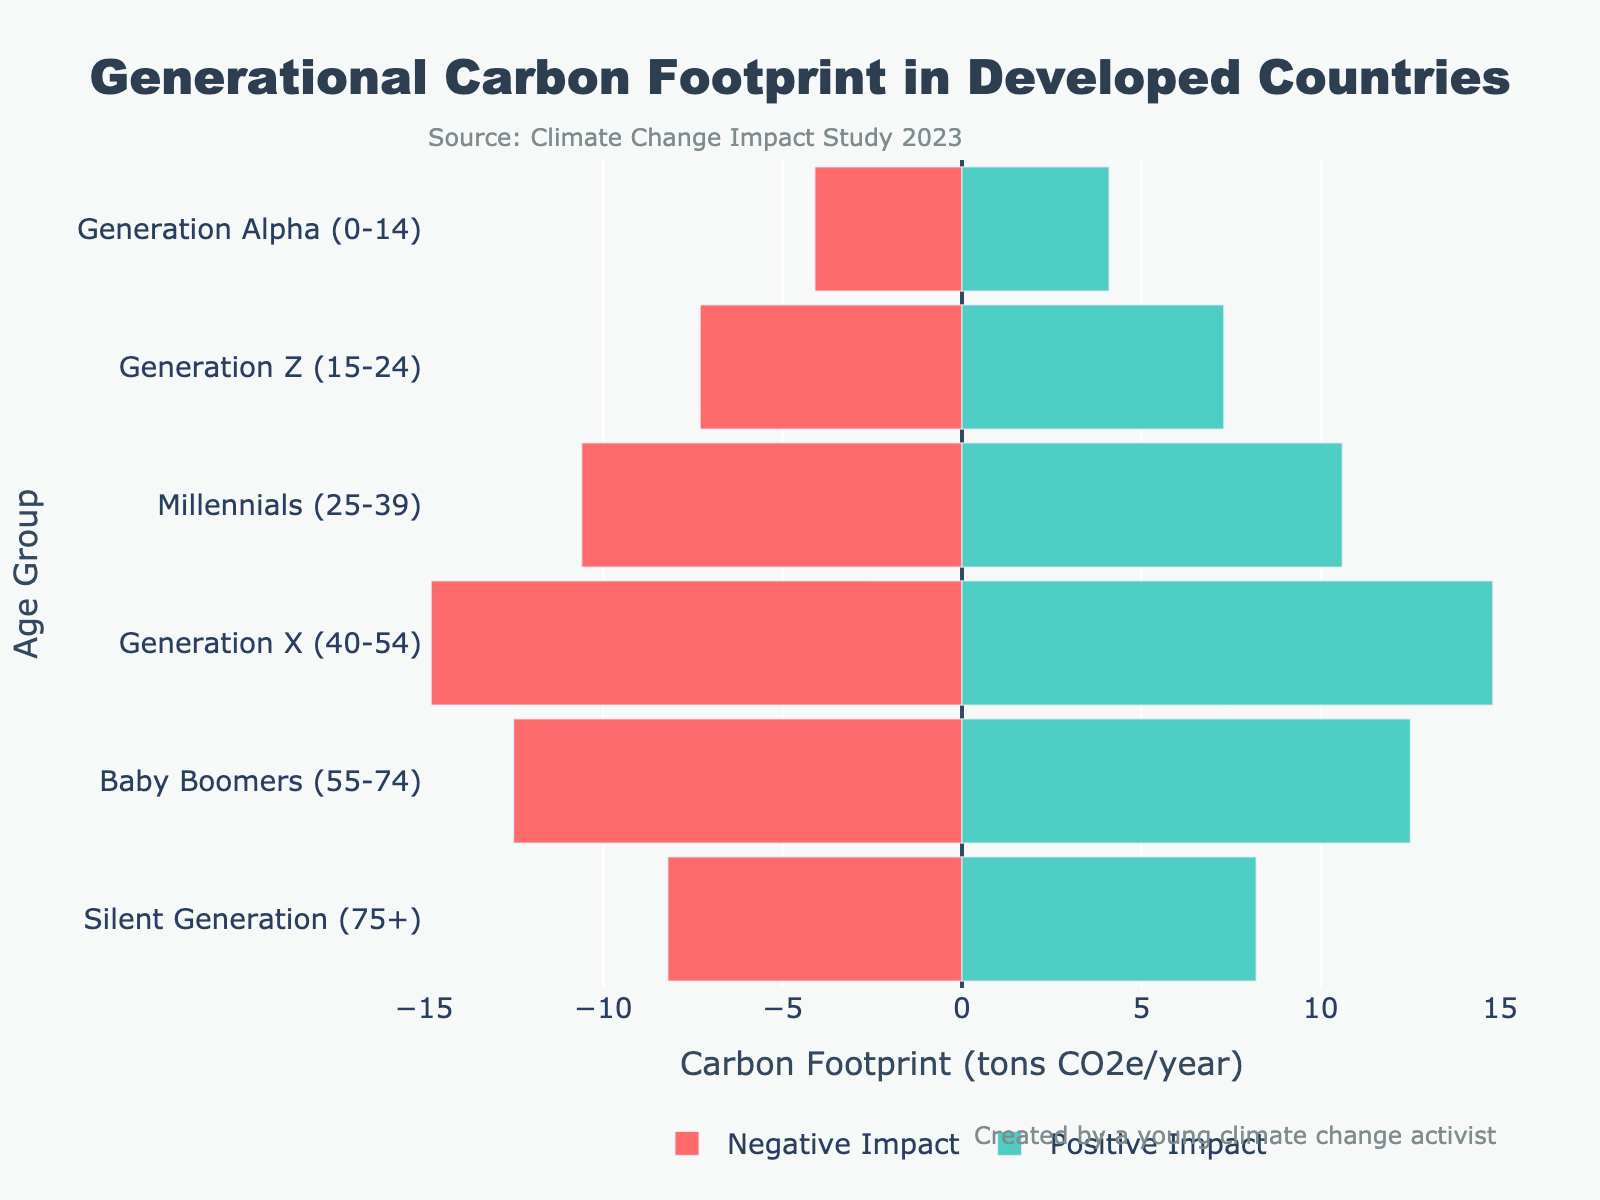What is the carbon footprint of the Baby Boomers on the positive side? According to the figure, on the right side where positive impacts are displayed, the Baby Boomers have a carbon footprint of 12.5 tons CO2e/year.
Answer: 12.5 tons CO2e/year Which generation has the highest negative carbon footprint? From the left side of the figure, which shows negative impacts, Generation X has the highest value with 14.8 tons CO2e/year.
Answer: Generation X Compare the carbon footprints of Millennials on both the positive and negative sides. On the left side, the negative impact for Millennials is 10.6 tons CO2e/year and on the right side, the positive impact is also 10.6 tons CO2e/year.
Answer: Both 10.6 tons CO2e/year What is the sum of negative carbon footprints for all generations? Adding up the negative impacts for all generations: 8.2 + 12.5 + 14.8 + 10.6 + 7.3 + 4.1 = 57.5 tons CO2e/year.
Answer: 57.5 tons CO2e/year How much greater is the positive carbon footprint of Generation X than that of Generation Z? The positive impact for Generation X is 14.8 tons CO2e/year and for Generation Z it is 7.3 tons CO2e/year. The difference is 14.8 - 7.3 = 7.5 tons CO2e/year.
Answer: 7.5 tons CO2e/year Which generation shows an equal positive and negative carbon footprint? By examining the bars on both sides of the figure, Millennials have equal positive and negative values of 10.6 tons CO2e/year.
Answer: Millennials What is the average positive carbon footprint for all generations? Adding up the positive footprints: 8.2 + 12.5 + 14.8 + 10.6 + 7.3 + 4.1 = 57.5 tons CO2e/year, and dividing by 6 generations: 57.5 / 6 ≈ 9.58 tons CO2e/year.
Answer: 9.58 tons CO2e/year How does the carbon footprint of Generation Alpha compare to that of the Silent Generation on the negative side? The negative impact for Generation Alpha is 4.1 tons CO2e/year, while for the Silent Generation it is 8.2 tons CO2e/year. Generation Alpha's footprint is smaller by 4.1 tons CO2e/year.
Answer: Generation Alpha has a smaller footprint by 4.1 tons CO2e/year 